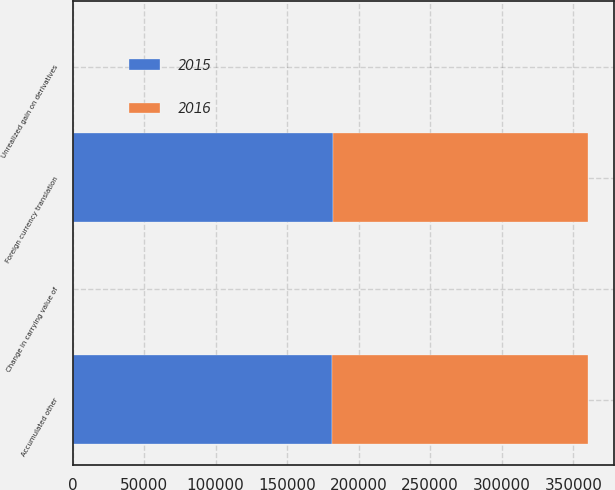Convert chart. <chart><loc_0><loc_0><loc_500><loc_500><stacked_bar_chart><ecel><fcel>Foreign currency translation<fcel>Change in carrying value of<fcel>Unrealized gain on derivatives<fcel>Accumulated other<nl><fcel>2016<fcel>178577<fcel>232<fcel>60<fcel>178583<nl><fcel>2015<fcel>181725<fcel>232<fcel>11<fcel>181482<nl></chart> 